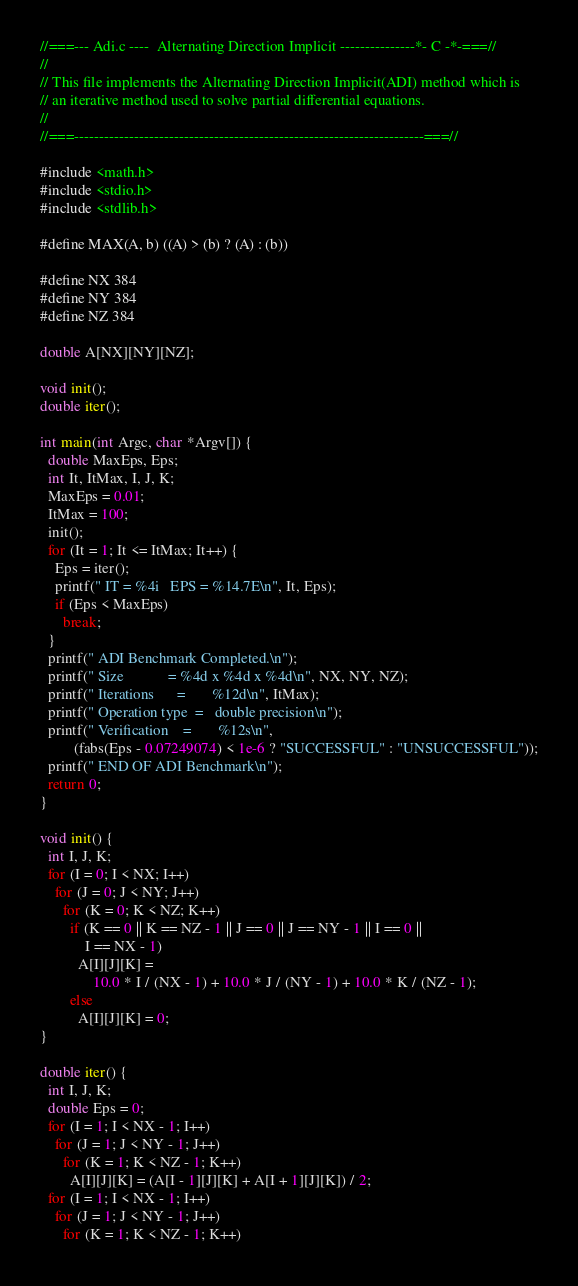<code> <loc_0><loc_0><loc_500><loc_500><_C_>//===--- Adi.c ----  Alternating Direction Implicit ---------------*- C -*-===//
//
// This file implements the Alternating Direction Implicit(ADI) method which is
// an iterative method used to solve partial differential equations.
//
//===----------------------------------------------------------------------===//

#include <math.h>
#include <stdio.h>
#include <stdlib.h>

#define MAX(A, b) ((A) > (b) ? (A) : (b))

#define NX 384
#define NY 384
#define NZ 384

double A[NX][NY][NZ];

void init();
double iter();

int main(int Argc, char *Argv[]) {
  double MaxEps, Eps;
  int It, ItMax, I, J, K;
  MaxEps = 0.01;
  ItMax = 100;
  init();
  for (It = 1; It <= ItMax; It++) {
    Eps = iter();
    printf(" IT = %4i   EPS = %14.7E\n", It, Eps);
    if (Eps < MaxEps)
      break;
  }
  printf(" ADI Benchmark Completed.\n");
  printf(" Size            = %4d x %4d x %4d\n", NX, NY, NZ);
  printf(" Iterations      =       %12d\n", ItMax);
  printf(" Operation type  =   double precision\n");
  printf(" Verification    =       %12s\n",
         (fabs(Eps - 0.07249074) < 1e-6 ? "SUCCESSFUL" : "UNSUCCESSFUL"));
  printf(" END OF ADI Benchmark\n");
  return 0;
}

void init() {
  int I, J, K;
  for (I = 0; I < NX; I++)
    for (J = 0; J < NY; J++)
      for (K = 0; K < NZ; K++)
        if (K == 0 || K == NZ - 1 || J == 0 || J == NY - 1 || I == 0 ||
            I == NX - 1)
          A[I][J][K] =
              10.0 * I / (NX - 1) + 10.0 * J / (NY - 1) + 10.0 * K / (NZ - 1);
        else
          A[I][J][K] = 0;
}

double iter() {
  int I, J, K;
  double Eps = 0;
  for (I = 1; I < NX - 1; I++)
    for (J = 1; J < NY - 1; J++)
      for (K = 1; K < NZ - 1; K++)
        A[I][J][K] = (A[I - 1][J][K] + A[I + 1][J][K]) / 2;
  for (I = 1; I < NX - 1; I++)
    for (J = 1; J < NY - 1; J++)
      for (K = 1; K < NZ - 1; K++)</code> 